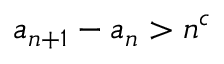<formula> <loc_0><loc_0><loc_500><loc_500>a _ { n + 1 } - a _ { n } > n ^ { c }</formula> 